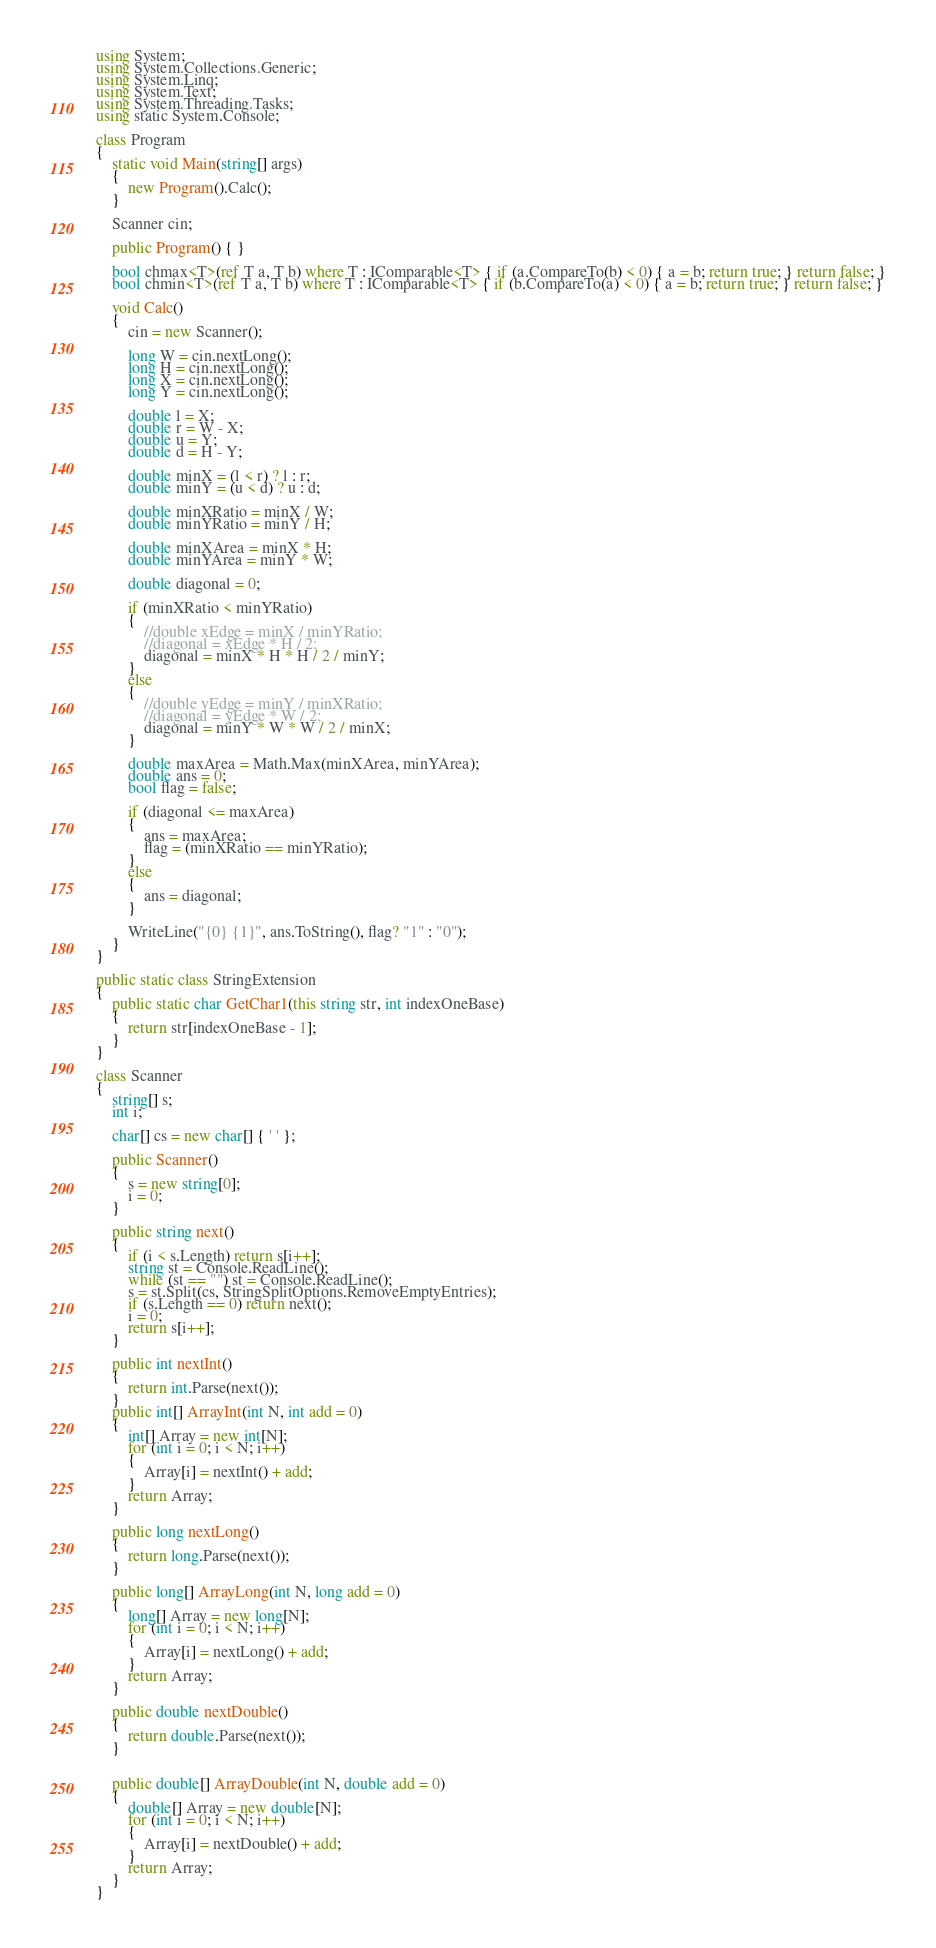Convert code to text. <code><loc_0><loc_0><loc_500><loc_500><_C#_>using System;
using System.Collections.Generic;
using System.Linq;
using System.Text;
using System.Threading.Tasks;
using static System.Console;

class Program
{
    static void Main(string[] args)
    {
        new Program().Calc();
    }

    Scanner cin;

    public Program() { }

    bool chmax<T>(ref T a, T b) where T : IComparable<T> { if (a.CompareTo(b) < 0) { a = b; return true; } return false; }
    bool chmin<T>(ref T a, T b) where T : IComparable<T> { if (b.CompareTo(a) < 0) { a = b; return true; } return false; }

    void Calc()
    {
        cin = new Scanner();

        long W = cin.nextLong();
        long H = cin.nextLong();
        long X = cin.nextLong();
        long Y = cin.nextLong();

        double l = X;
        double r = W - X;
        double u = Y;
        double d = H - Y;

        double minX = (l < r) ? l : r;
        double minY = (u < d) ? u : d;

        double minXRatio = minX / W;
        double minYRatio = minY / H;

        double minXArea = minX * H;
        double minYArea = minY * W;

        double diagonal = 0;

        if (minXRatio < minYRatio)
        {
            //double xEdge = minX / minYRatio;
            //diagonal = xEdge * H / 2;
            diagonal = minX * H * H / 2 / minY;
        }
        else
        {
            //double yEdge = minY / minXRatio;
            //diagonal = yEdge * W / 2;
            diagonal = minY * W * W / 2 / minX;
        }

        double maxArea = Math.Max(minXArea, minYArea);
        double ans = 0;
        bool flag = false;

        if (diagonal <= maxArea)
        {
            ans = maxArea;
            flag = (minXRatio == minYRatio);
        }
        else
        {
            ans = diagonal;
        }

        WriteLine("{0} {1}", ans.ToString(), flag? "1" : "0");
    }
}

public static class StringExtension
{
    public static char GetChar1(this string str, int indexOneBase)
    {
        return str[indexOneBase - 1];
    }
}

class Scanner
{
    string[] s;
    int i;

    char[] cs = new char[] { ' ' };

    public Scanner()
    {
        s = new string[0];
        i = 0;
    }

    public string next()
    {
        if (i < s.Length) return s[i++];
        string st = Console.ReadLine();
        while (st == "") st = Console.ReadLine();
        s = st.Split(cs, StringSplitOptions.RemoveEmptyEntries);
        if (s.Length == 0) return next();
        i = 0;
        return s[i++];
    }

    public int nextInt()
    {
        return int.Parse(next());
    }
    public int[] ArrayInt(int N, int add = 0)
    {
        int[] Array = new int[N];
        for (int i = 0; i < N; i++)
        {
            Array[i] = nextInt() + add;
        }
        return Array;
    }

    public long nextLong()
    {
        return long.Parse(next());
    }

    public long[] ArrayLong(int N, long add = 0)
    {
        long[] Array = new long[N];
        for (int i = 0; i < N; i++)
        {
            Array[i] = nextLong() + add;
        }
        return Array;
    }

    public double nextDouble()
    {
        return double.Parse(next());
    }


    public double[] ArrayDouble(int N, double add = 0)
    {
        double[] Array = new double[N];
        for (int i = 0; i < N; i++)
        {
            Array[i] = nextDouble() + add;
        }
        return Array;
    }
}
</code> 